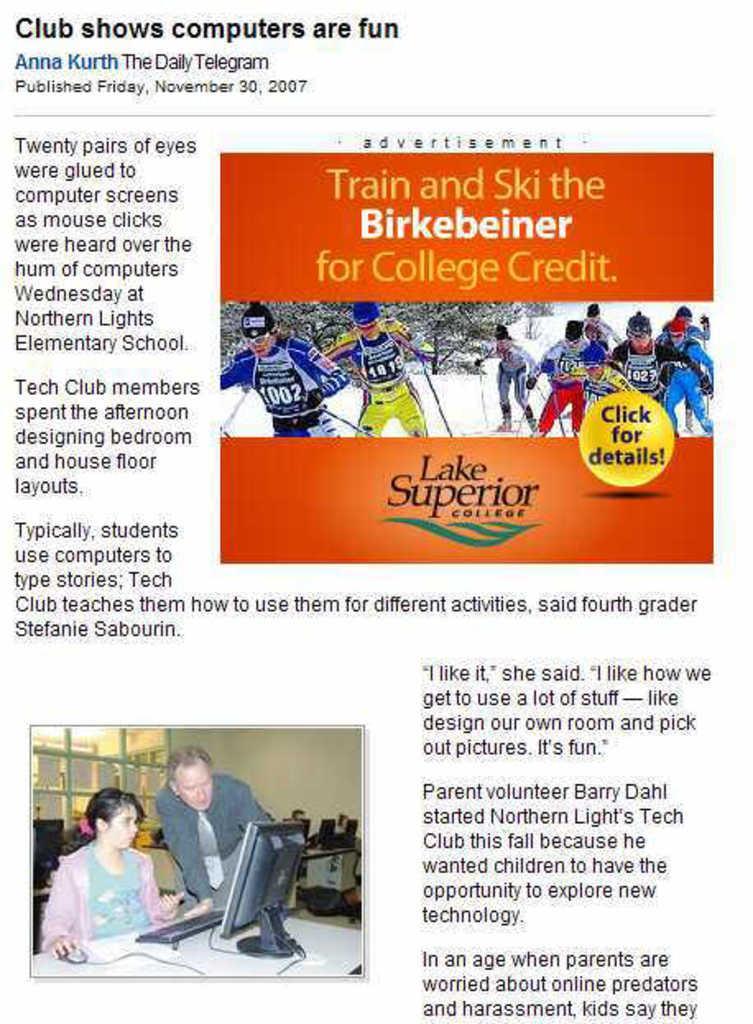Can you describe this image briefly? In this picture, it looks like a poster and on the poster, there are images of people. On the poster, it is written something. 